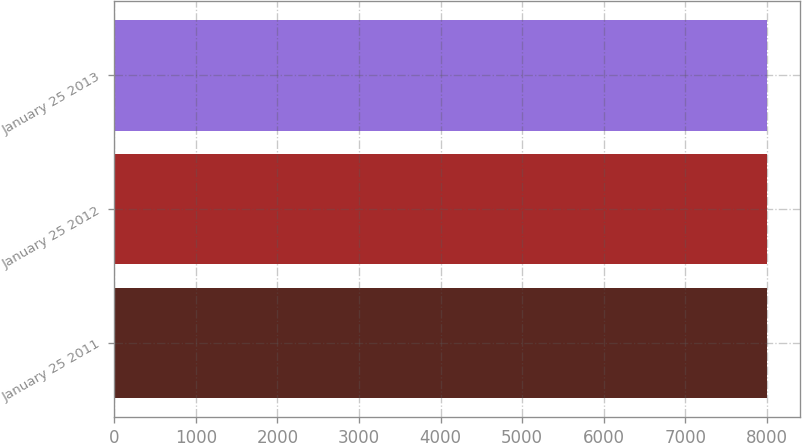Convert chart to OTSL. <chart><loc_0><loc_0><loc_500><loc_500><bar_chart><fcel>January 25 2011<fcel>January 25 2012<fcel>January 25 2013<nl><fcel>8000<fcel>8000.1<fcel>8000.2<nl></chart> 